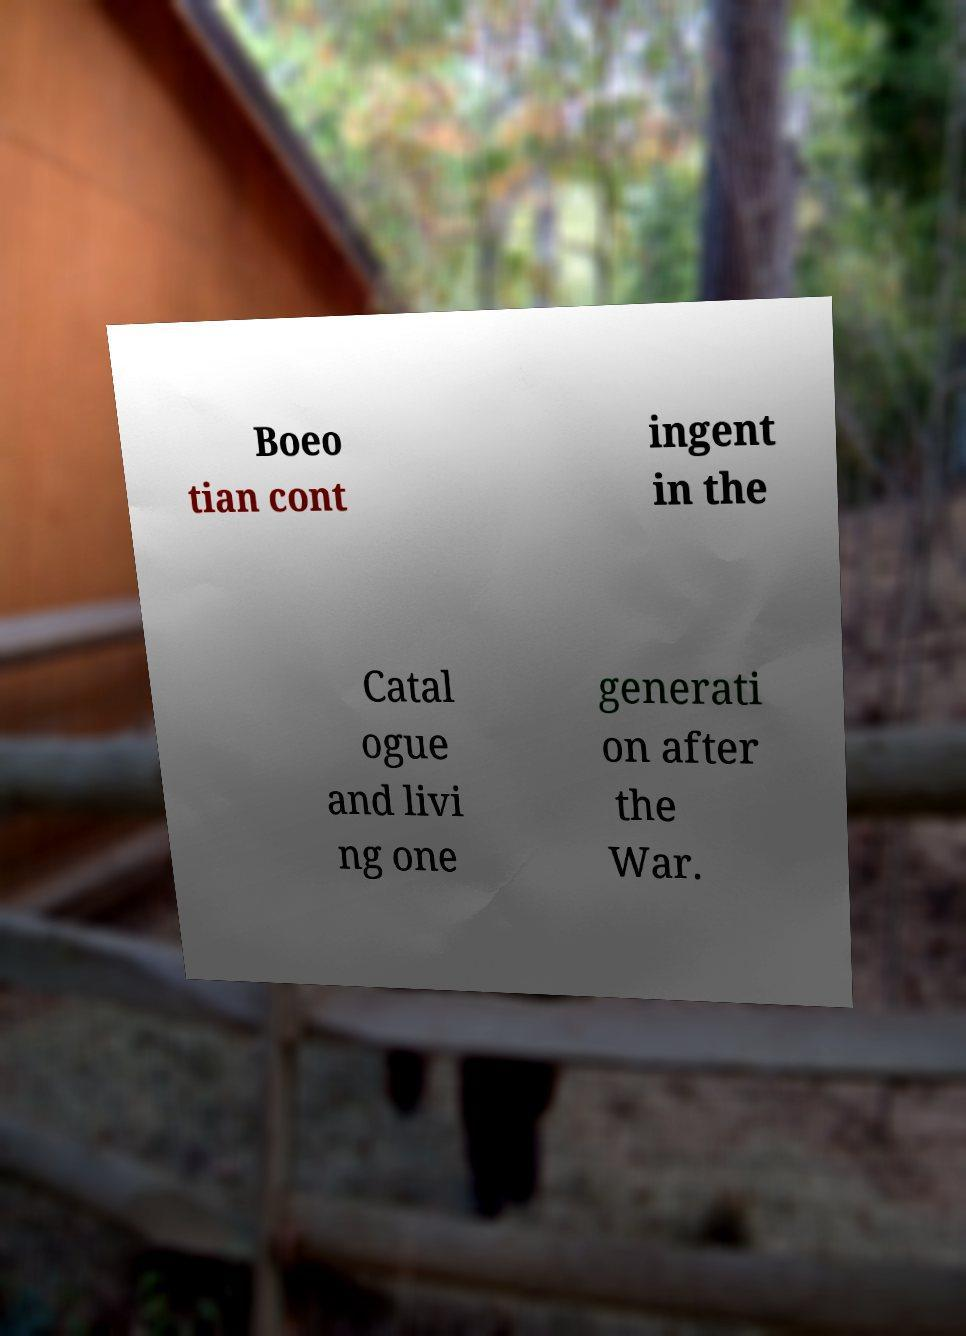Please identify and transcribe the text found in this image. Boeo tian cont ingent in the Catal ogue and livi ng one generati on after the War. 